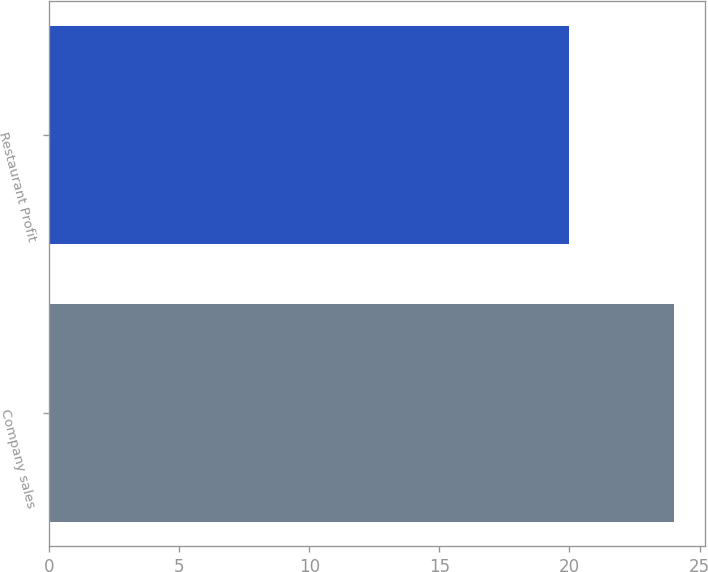Convert chart. <chart><loc_0><loc_0><loc_500><loc_500><bar_chart><fcel>Company sales<fcel>Restaurant Profit<nl><fcel>24<fcel>20<nl></chart> 